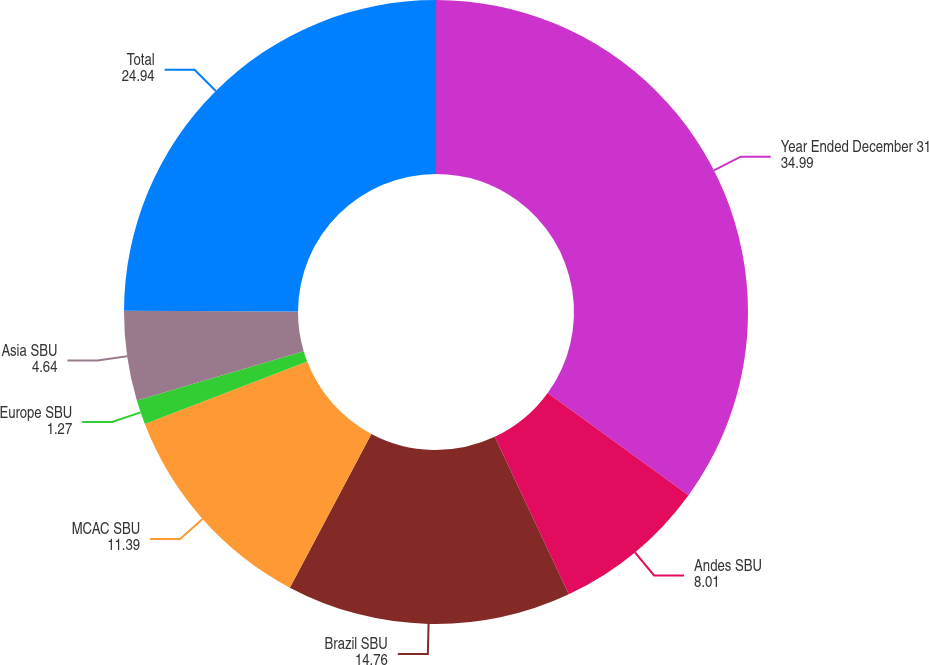<chart> <loc_0><loc_0><loc_500><loc_500><pie_chart><fcel>Year Ended December 31<fcel>Andes SBU<fcel>Brazil SBU<fcel>MCAC SBU<fcel>Europe SBU<fcel>Asia SBU<fcel>Total<nl><fcel>34.99%<fcel>8.01%<fcel>14.76%<fcel>11.39%<fcel>1.27%<fcel>4.64%<fcel>24.94%<nl></chart> 